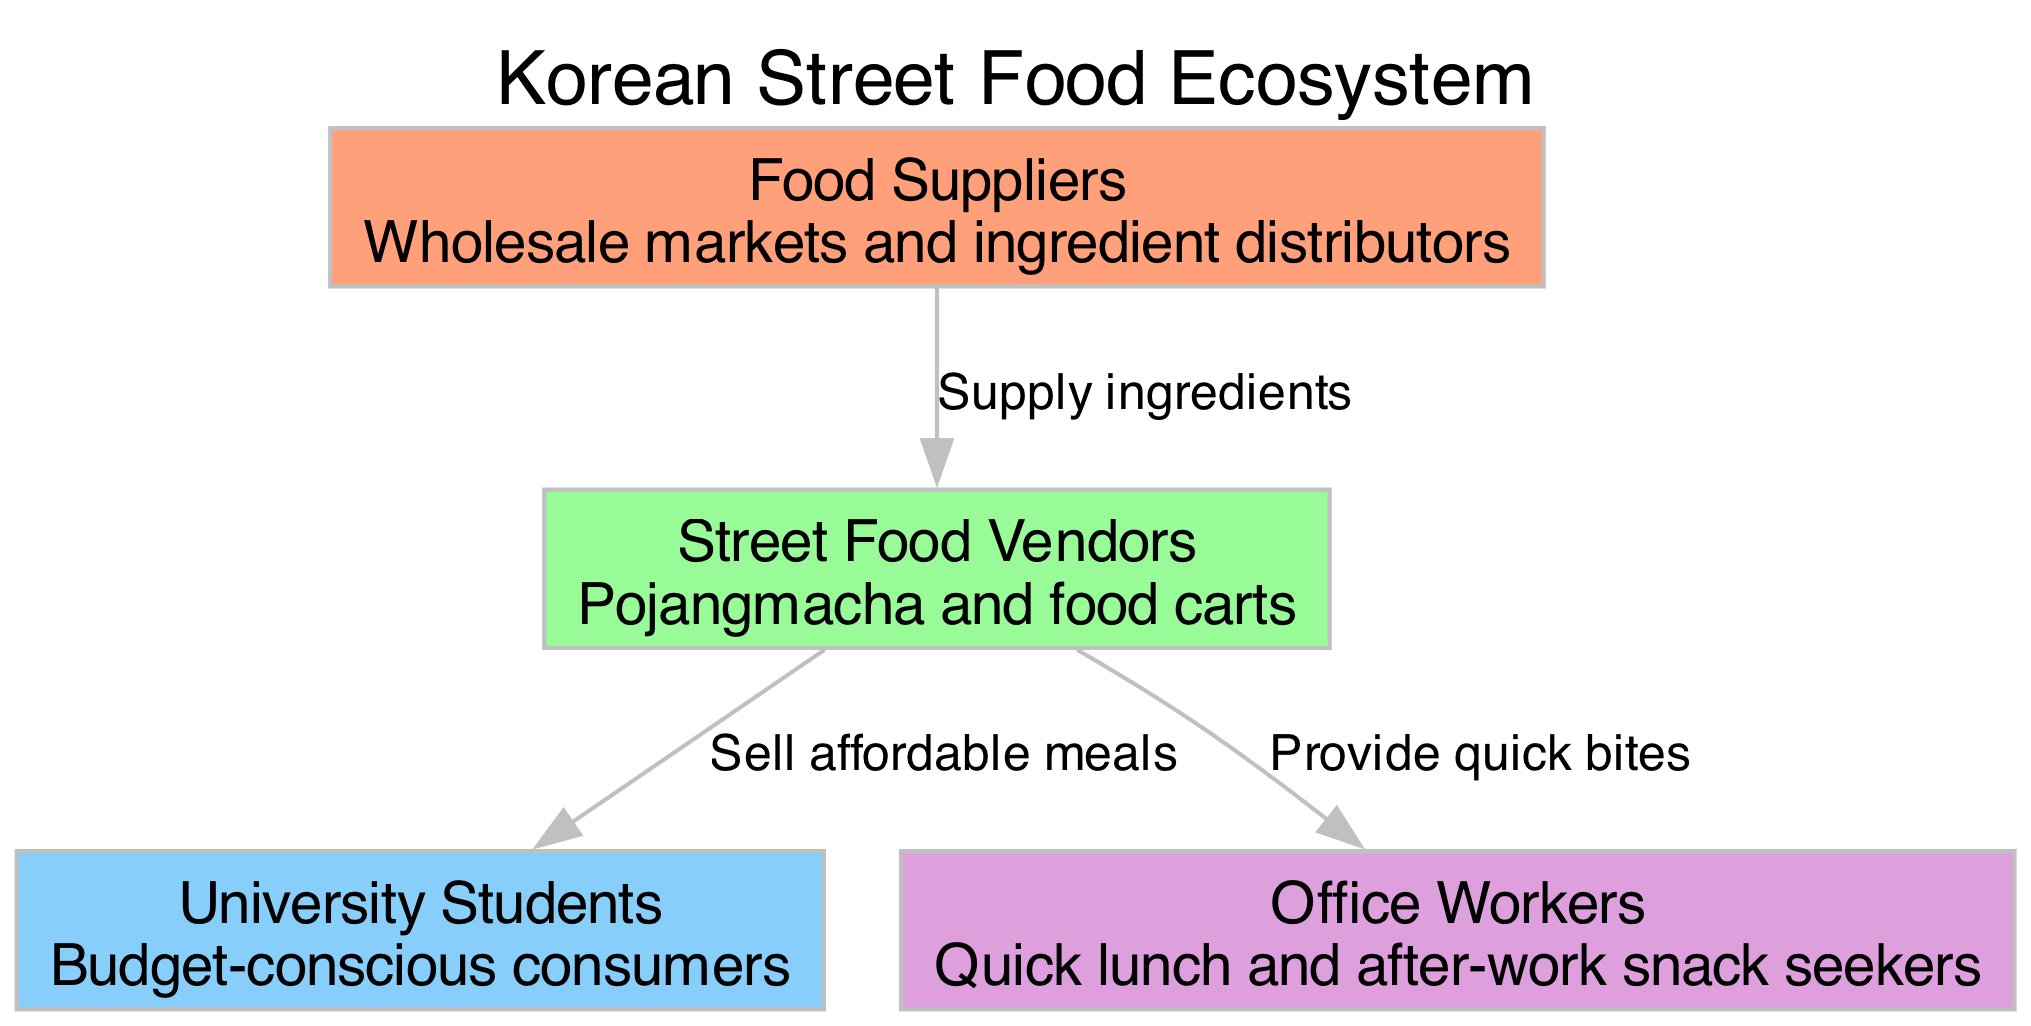What are the nodes in the diagram? The nodes in the diagram represent different entities in the Korean street food ecosystem: Food Suppliers, Street Food Vendors, University Students, and Office Workers. Each node is distinct and fulfills a specific role in the ecosystem.
Answer: Food Suppliers, Street Food Vendors, University Students, Office Workers How many nodes are present in the diagram? The diagram contains four nodes which are Food Suppliers, Street Food Vendors, University Students, and Office Workers. Each of these nodes can be counted individually to arrive at the total.
Answer: 4 What is the relationship between Food Suppliers and Street Food Vendors? According to the diagram, Food Suppliers supply ingredients to Street Food Vendors. This indicates a direct transactional relationship where vendors rely on suppliers for their raw materials.
Answer: Supply ingredients Which node sells affordable meals? The Street Food Vendors sell affordable meals to University Students, catering specifically to their budget-conscious nature. This is indicated by the directed edge from Street Food Vendors to University Students labeled accordingly.
Answer: Street Food Vendors What do Street Food Vendors provide to Office Workers? Street Food Vendors provide quick bites to Office Workers, as shown by the directed edge between the two nodes. This indicates that vendors target this group for convenient meal options, particularly around lunch or after work hours.
Answer: Quick bites How many edges connect the nodes? There are three edges in the diagram that represent the interactions between the nodes. Each edge describes a specific type of flow or relationship that exists among the entities depicted.
Answer: 3 Which type of consumers are University Students classified as? University Students are classified as budget-conscious consumers in the diagram. This description emphasizes their behavior in seeking affordable and accessible meal options from street food vendors.
Answer: Budget-conscious consumers What do Food Suppliers do? Food Suppliers are responsible for supplying ingredients to Street Food Vendors. This role is crucial as it establishes the starting point of the food chain in the ecosystem.
Answer: Supply ingredients What do Street Food Vendors offer to University Students? Street Food Vendors offer affordable meals to University Students. This connection emphasizes the primary target market for the vendors and highlights their role in the food ecosystem.
Answer: Affordable meals 